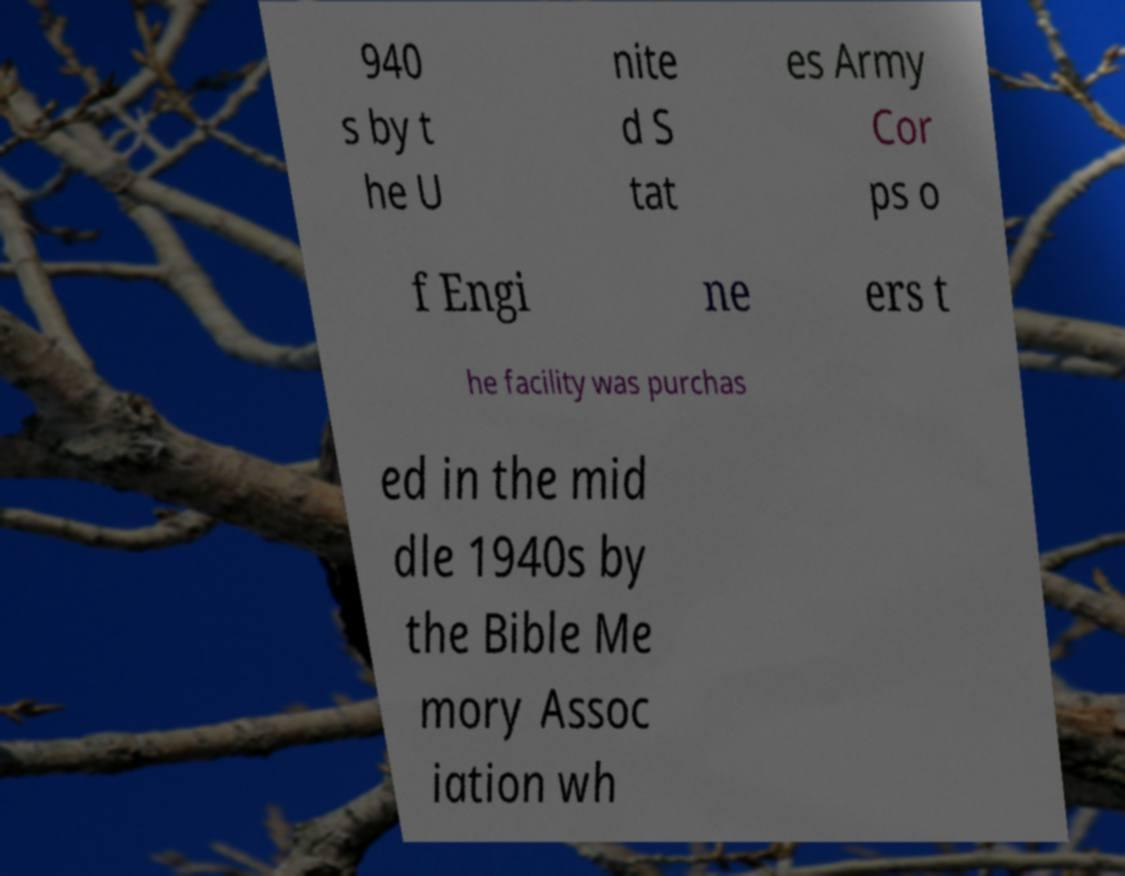Please identify and transcribe the text found in this image. 940 s by t he U nite d S tat es Army Cor ps o f Engi ne ers t he facility was purchas ed in the mid dle 1940s by the Bible Me mory Assoc iation wh 